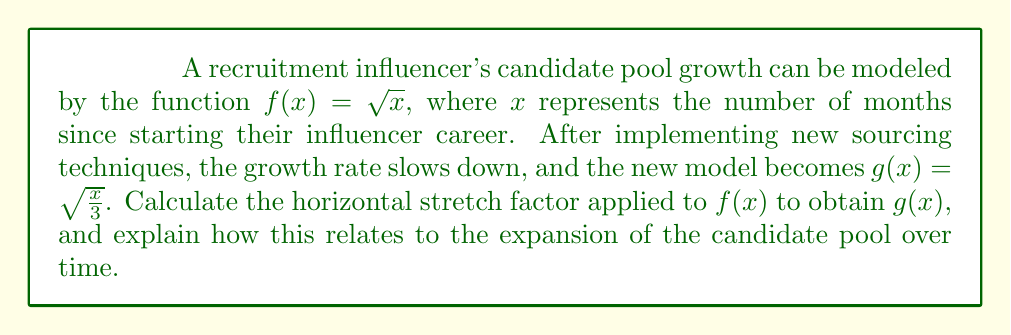Help me with this question. To solve this problem, we need to understand the concept of horizontal stretches in function transformations. A horizontal stretch by a factor of $a$ transforms a function $f(x)$ into $f(\frac{x}{a})$, where $a > 1$.

Let's approach this step-by-step:

1) We start with $f(x) = \sqrt{x}$ and need to find the transformation to get $g(x) = \sqrt{\frac{x}{3}}$.

2) We can rewrite $g(x)$ as:
   $$g(x) = \sqrt{\frac{x}{3}} = \sqrt{\frac{1}{3}x} = \frac{1}{\sqrt{3}}\sqrt{x}$$

3) Now, we can see that $g(x) = \frac{1}{\sqrt{3}}f(x)$, which is a vertical stretch. However, we're asked about the horizontal stretch.

4) To get a horizontal stretch, we need to manipulate the input of $f$:
   $$g(x) = \sqrt{\frac{x}{3}} = f(\frac{x}{3})$$

5) This shows that $g(x)$ is indeed a horizontal stretch of $f(x)$ by a factor of 3.

In the context of candidate pool expansion, this means that after implementing the new sourcing techniques, it now takes 3 times as long to reach the same size candidate pool as it did with the original growth model. For example, if it originally took 4 months to reach a certain pool size, it would now take 12 months to reach the same size.

This slower growth could be interpreted as a more selective or quality-focused approach to building the candidate pool, which might be beneficial in terms of candidate quality even though the growth rate has decreased.
Answer: The horizontal stretch factor is 3. 